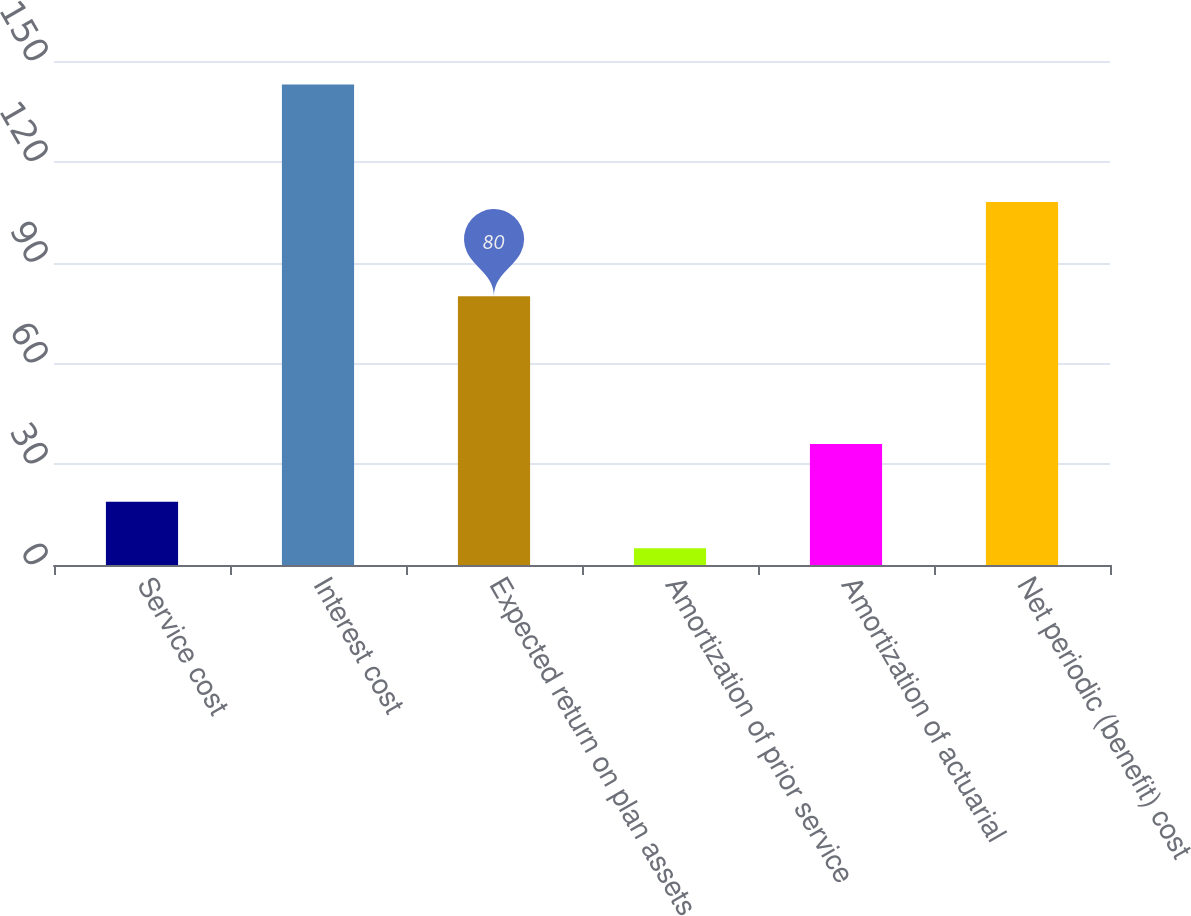Convert chart. <chart><loc_0><loc_0><loc_500><loc_500><bar_chart><fcel>Service cost<fcel>Interest cost<fcel>Expected return on plan assets<fcel>Amortization of prior service<fcel>Amortization of actuarial<fcel>Net periodic (benefit) cost<nl><fcel>18.8<fcel>143<fcel>80<fcel>5<fcel>36<fcel>108<nl></chart> 